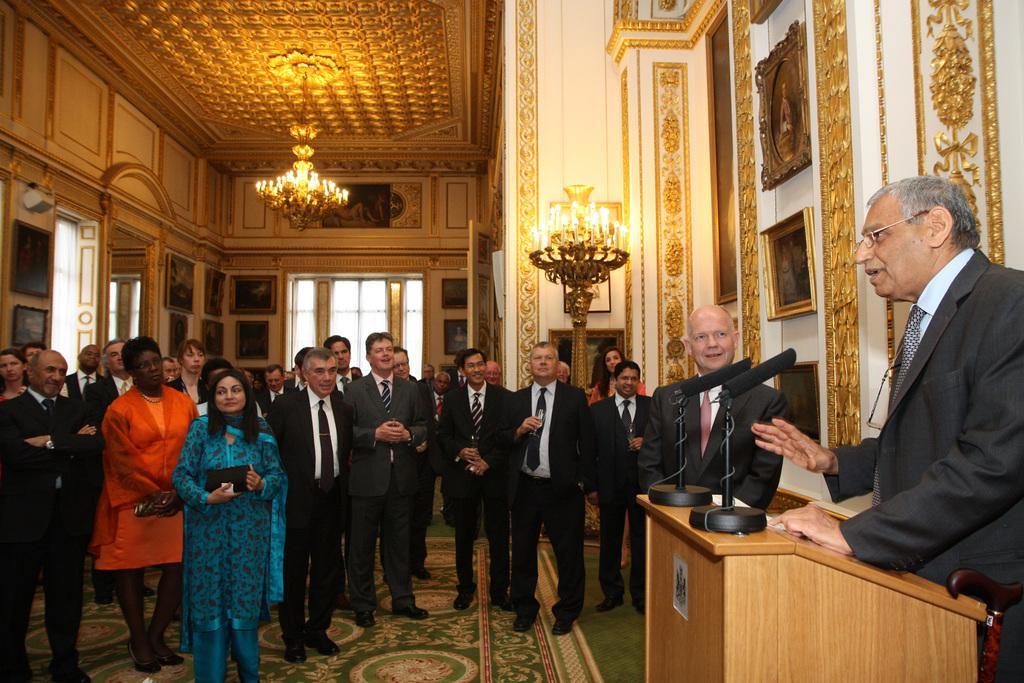Could you give a brief overview of what you see in this image? In this image the people are standing on the carpet which is laid on the floor and listening to the man who is speaking near the podium through the mic which is in front of him. At the top there is chandelier. At the background there are photo frames,windows and wall. 